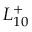<formula> <loc_0><loc_0><loc_500><loc_500>L _ { 1 0 } ^ { + }</formula> 